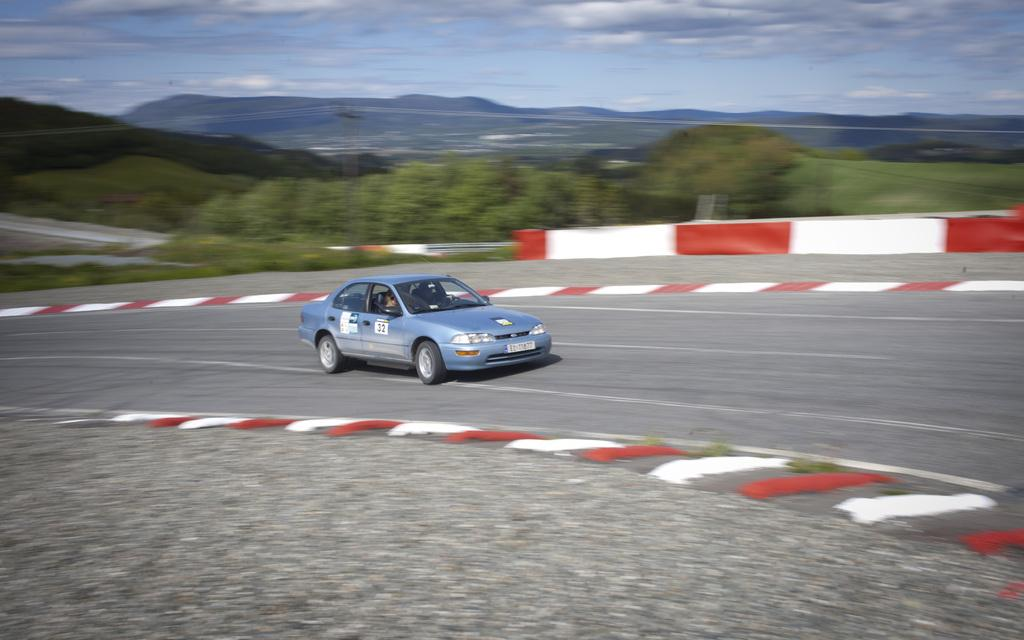What can be seen in the sky in the image? The sky with clouds is visible in the image. What type of natural features are present in the image? There are hills and trees in the image. What mode of transportation can be seen in the image? A motor vehicle is on the road in the image. What type of surface is present on the road in the image? There is a pavement in the image. What type of suit is the parent wearing in the image? There is no parent or suit present in the image. How many quinces are visible on the trees in the image? There are no quinces visible in the image; only trees are present. 